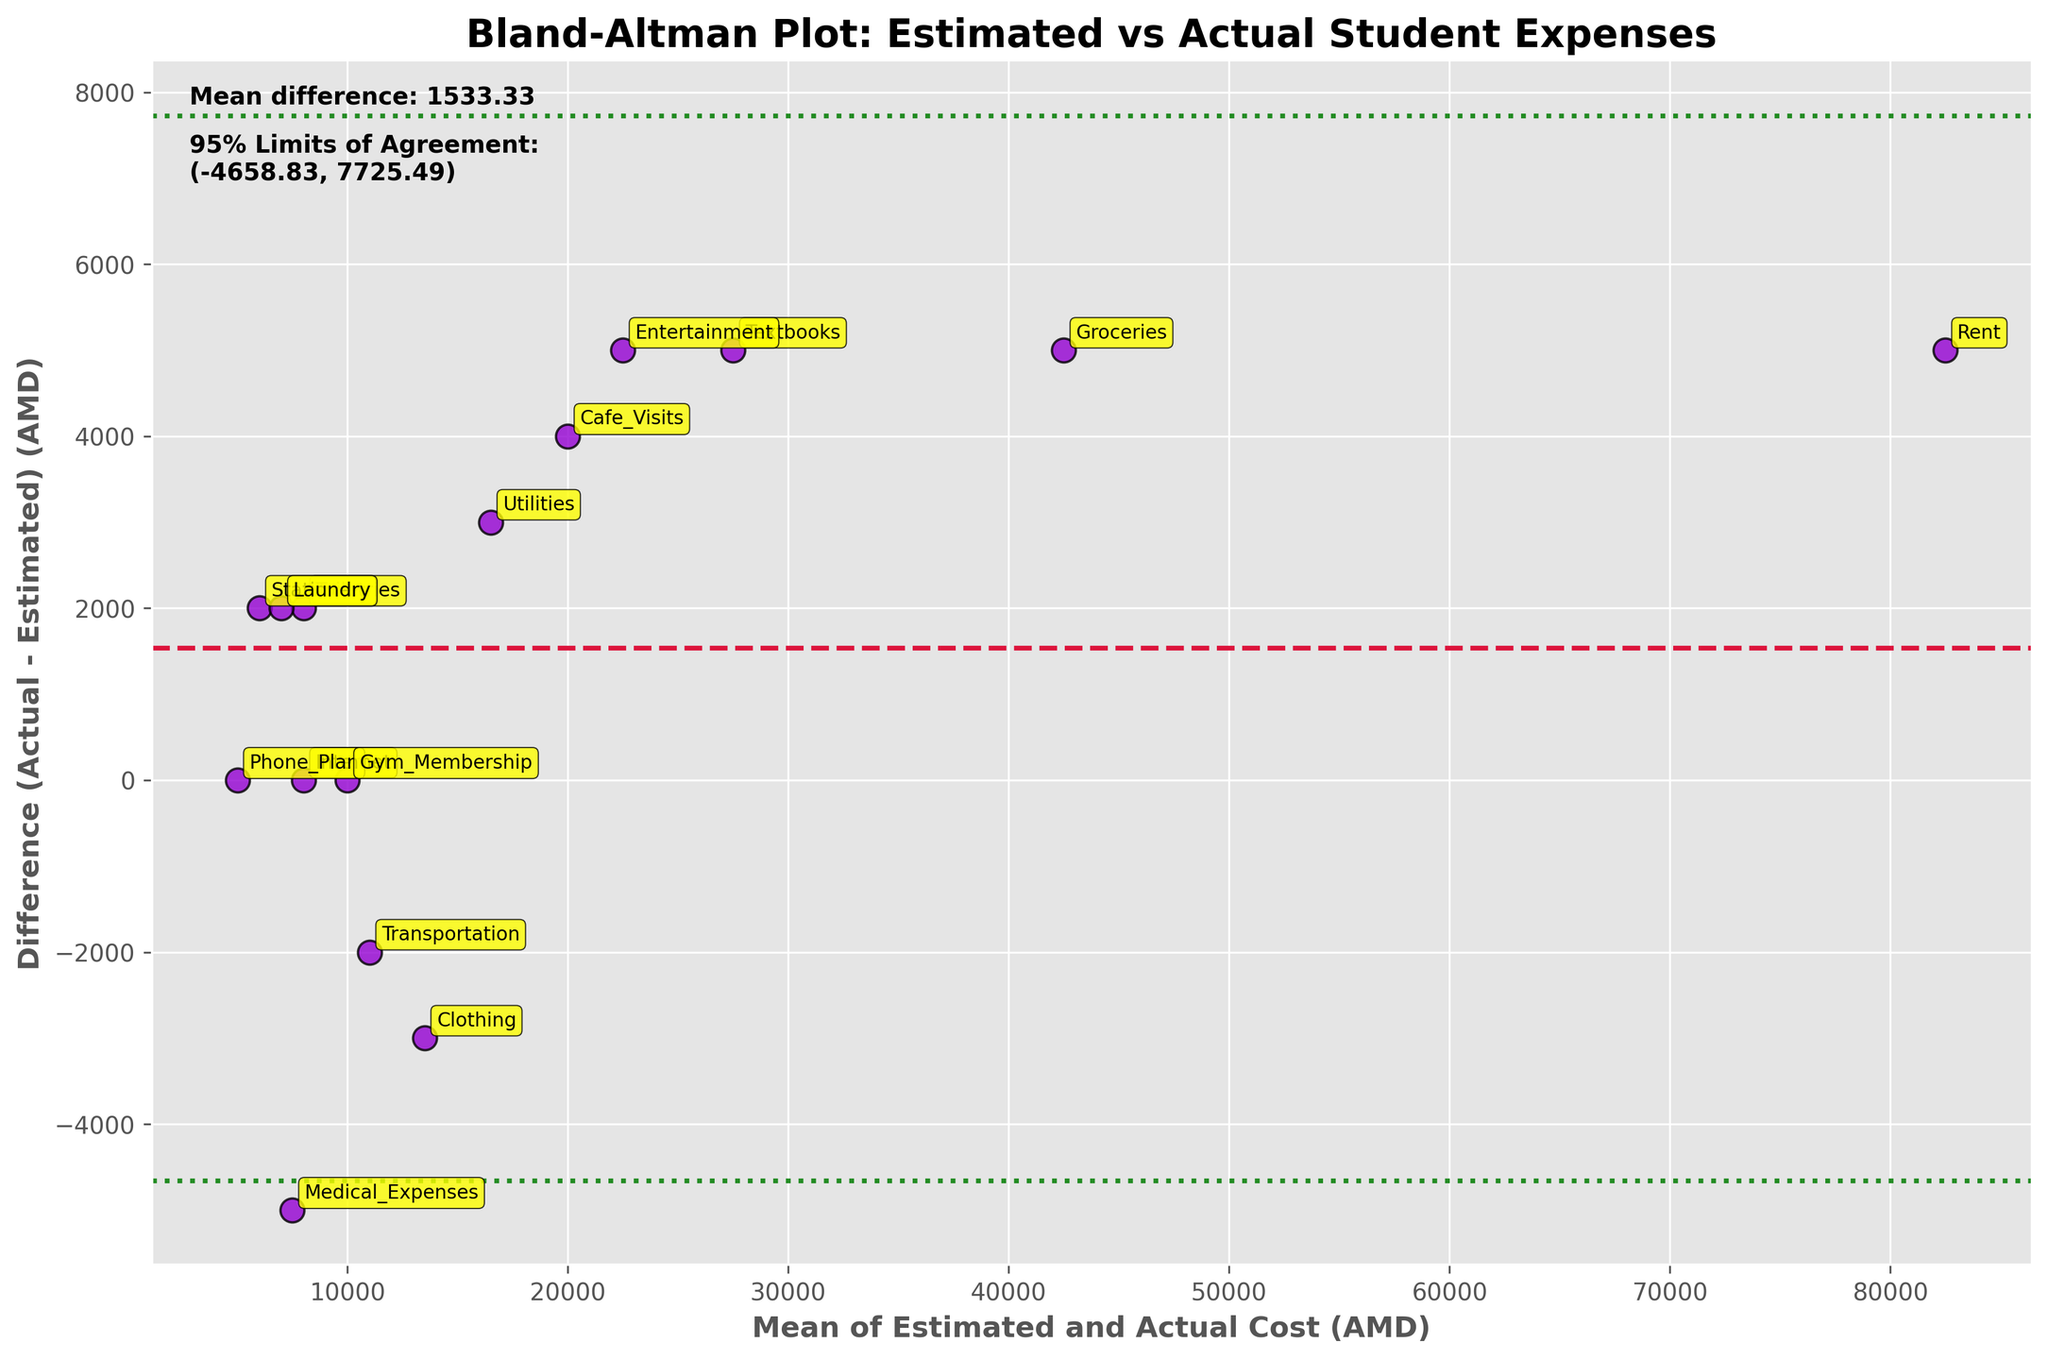how many data points are shown in the plot? Since each expense category represents one data point, and there are annotations for each category, count the number of annotated points.
Answer: 15 what is the average difference (Actual - Estimated) cost? The plot shows a horizontal dotted line representing the average difference. Reading the text box on the plot, the mean difference is explicitly stated.
Answer: 166.67 AMD what are the 95% limits of agreement? The limits of agreement are shown in the plot with two horizontal green dotted lines. The text box on the plot gives the numerical values.
Answer: (-5286.78, 5619.11) AMD which expense category has the highest actual cost compared to the estimated cost? Identify the point with the largest positive difference (vertical distance from the zero line upwards) and read its annotation.
Answer: Entertainment which expense category had no difference between estimated and actual costs? Look for points drawn on the zero line in the middle where the y-axis value is zero and check their annotations.
Answer: Internet and Gym Membership which expense category had the lowest actual cost compared to the estimated cost? Identify the point with the largest negative difference (vertical distance from the zero line downwards) and read its annotation.
Answer: Medical Expenses are the actual costs generally overestimated or underestimated? Determine the overall trend of the differences. If most points are above the zero line, actual costs were generally underestimated. If below, they were overestimated. The mean difference line helps to support this observation.
Answer: Underestimated what is the range of the mean of estimated and actual costs? Observe the x-axis values and find the minimum and maximum x-axis values where data points are placed.
Answer: 6,000 to 85,000 AMD how many expense categories exceed their estimated costs by more than 5000 AMD? Identify data points with a difference greater than 5000 AMD and count these points.
Answer: 4 what can be inferred if data points are outside the 95% limits of agreement? Analyze points outside the green dotted lines. It typically indicates that those data points have a significant discrepancy between estimated and actual costs.
Answer: Significant discrepancy 